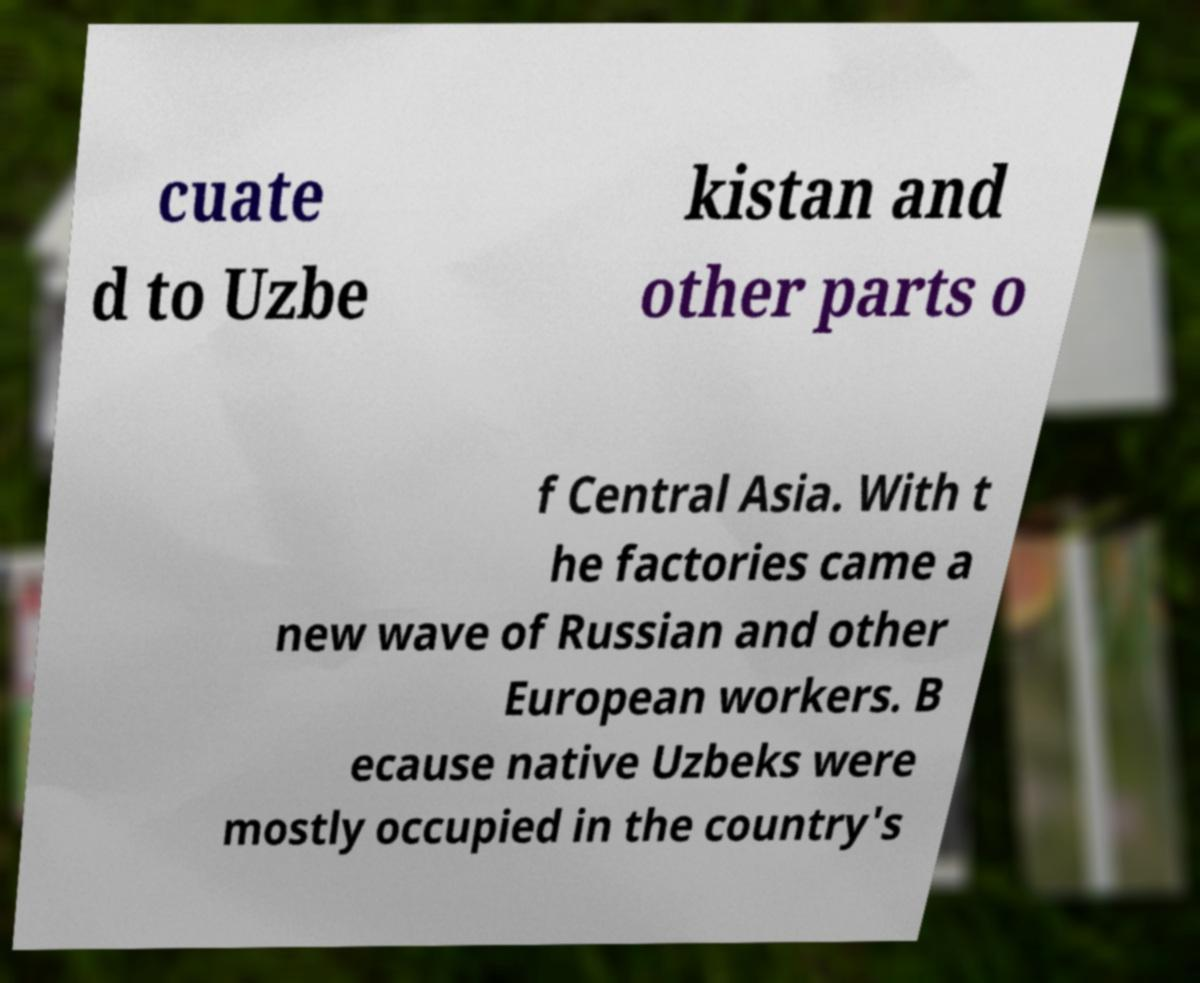What messages or text are displayed in this image? I need them in a readable, typed format. cuate d to Uzbe kistan and other parts o f Central Asia. With t he factories came a new wave of Russian and other European workers. B ecause native Uzbeks were mostly occupied in the country's 